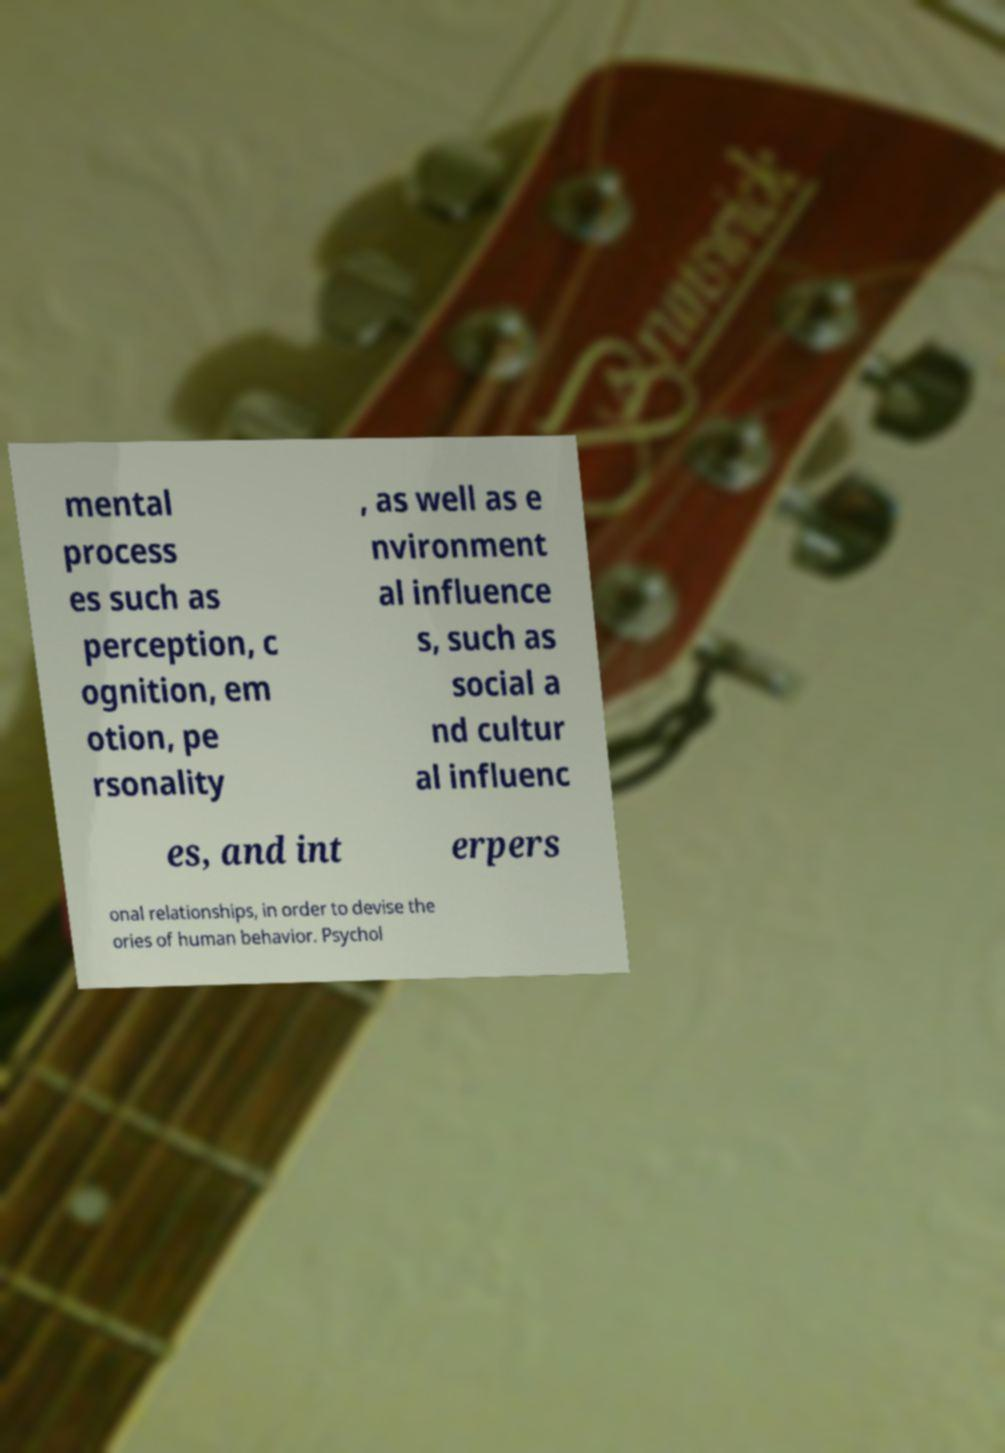Could you extract and type out the text from this image? mental process es such as perception, c ognition, em otion, pe rsonality , as well as e nvironment al influence s, such as social a nd cultur al influenc es, and int erpers onal relationships, in order to devise the ories of human behavior. Psychol 